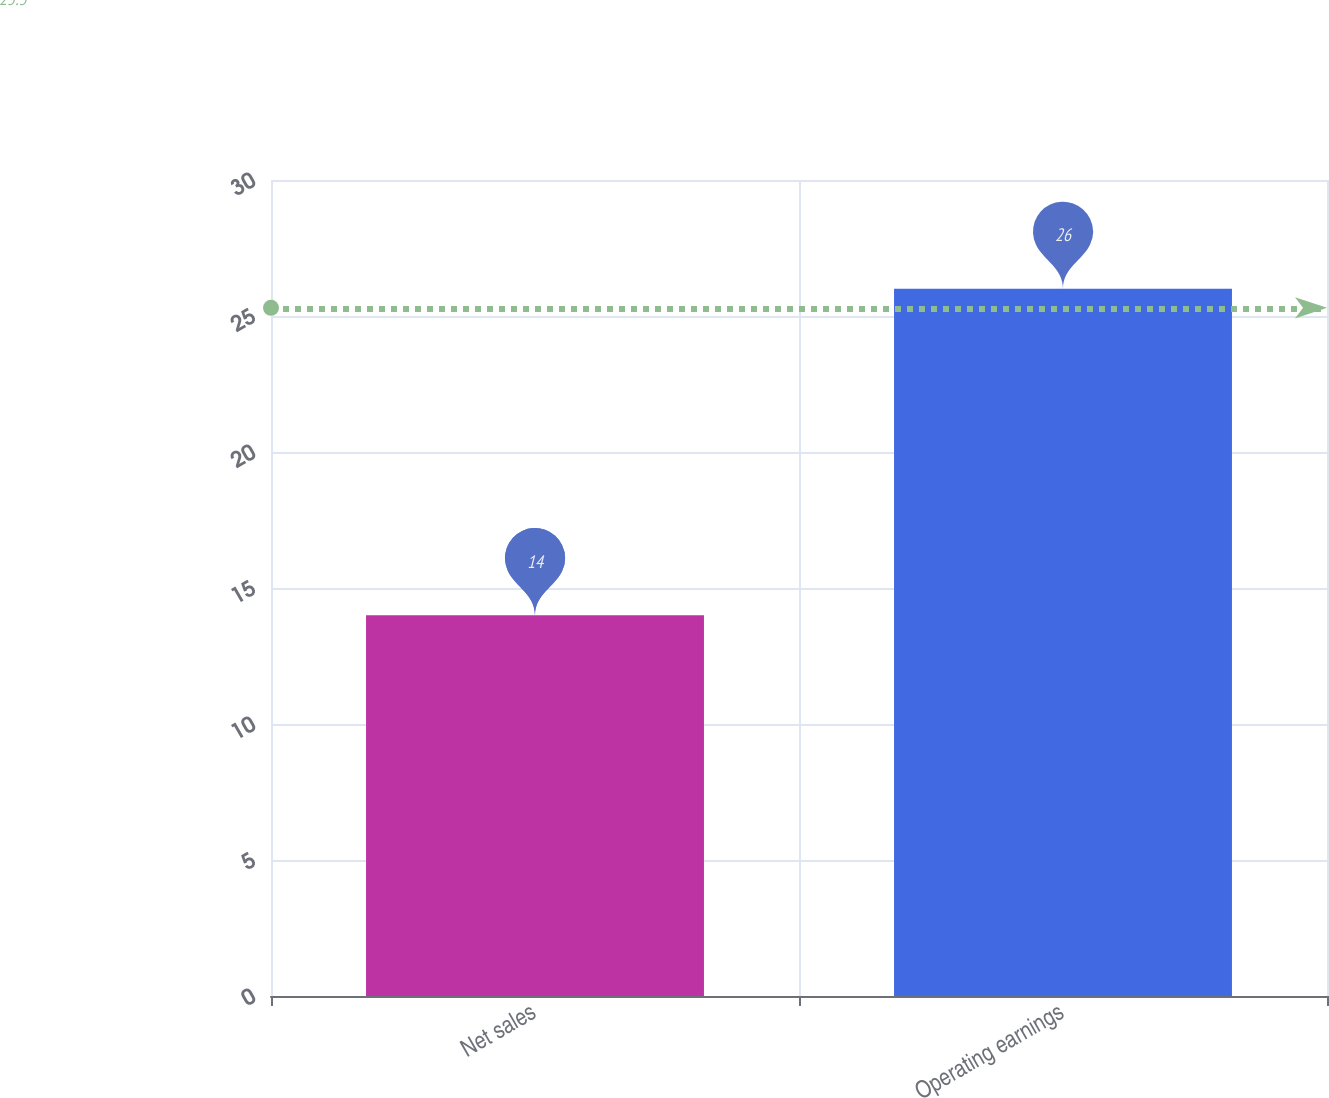<chart> <loc_0><loc_0><loc_500><loc_500><bar_chart><fcel>Net sales<fcel>Operating earnings<nl><fcel>14<fcel>26<nl></chart> 